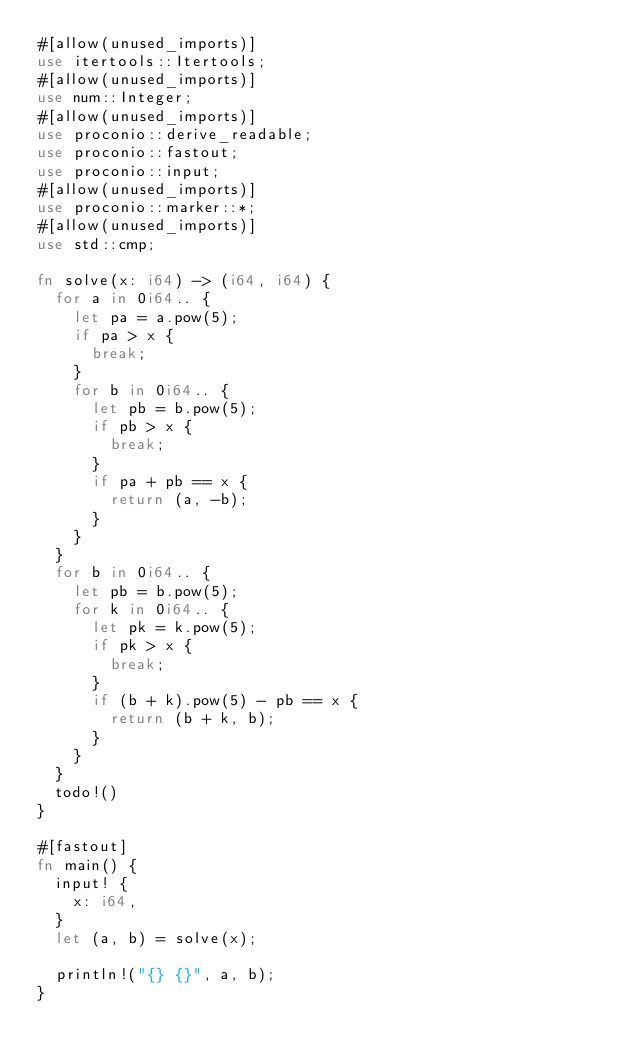<code> <loc_0><loc_0><loc_500><loc_500><_Rust_>#[allow(unused_imports)]
use itertools::Itertools;
#[allow(unused_imports)]
use num::Integer;
#[allow(unused_imports)]
use proconio::derive_readable;
use proconio::fastout;
use proconio::input;
#[allow(unused_imports)]
use proconio::marker::*;
#[allow(unused_imports)]
use std::cmp;

fn solve(x: i64) -> (i64, i64) {
  for a in 0i64.. {
    let pa = a.pow(5);
    if pa > x {
      break;
    }
    for b in 0i64.. {
      let pb = b.pow(5);
      if pb > x {
        break;
      }
      if pa + pb == x {
        return (a, -b);
      }
    }
  }
  for b in 0i64.. {
    let pb = b.pow(5);
    for k in 0i64.. {
      let pk = k.pow(5);
      if pk > x {
        break;
      }
      if (b + k).pow(5) - pb == x {
        return (b + k, b);
      }
    }
  }
  todo!()
}

#[fastout]
fn main() {
  input! {
    x: i64,
  }
  let (a, b) = solve(x);

  println!("{} {}", a, b);
}
</code> 